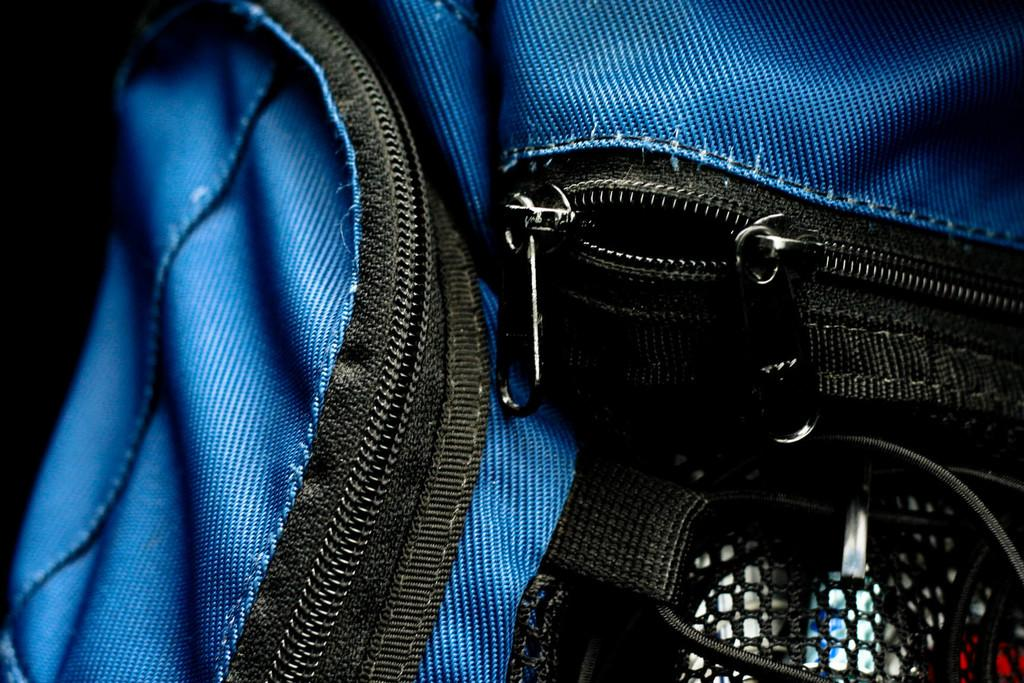What object can be seen in the picture? There is a bag in the picture. What color is the bag? The bag is blue. Are there any additional features on the bag? Yes, there are chains on the bag. What color are the chains? The chains are black. What type of card can be seen inside the bag? There is no card visible inside the bag in the image. 